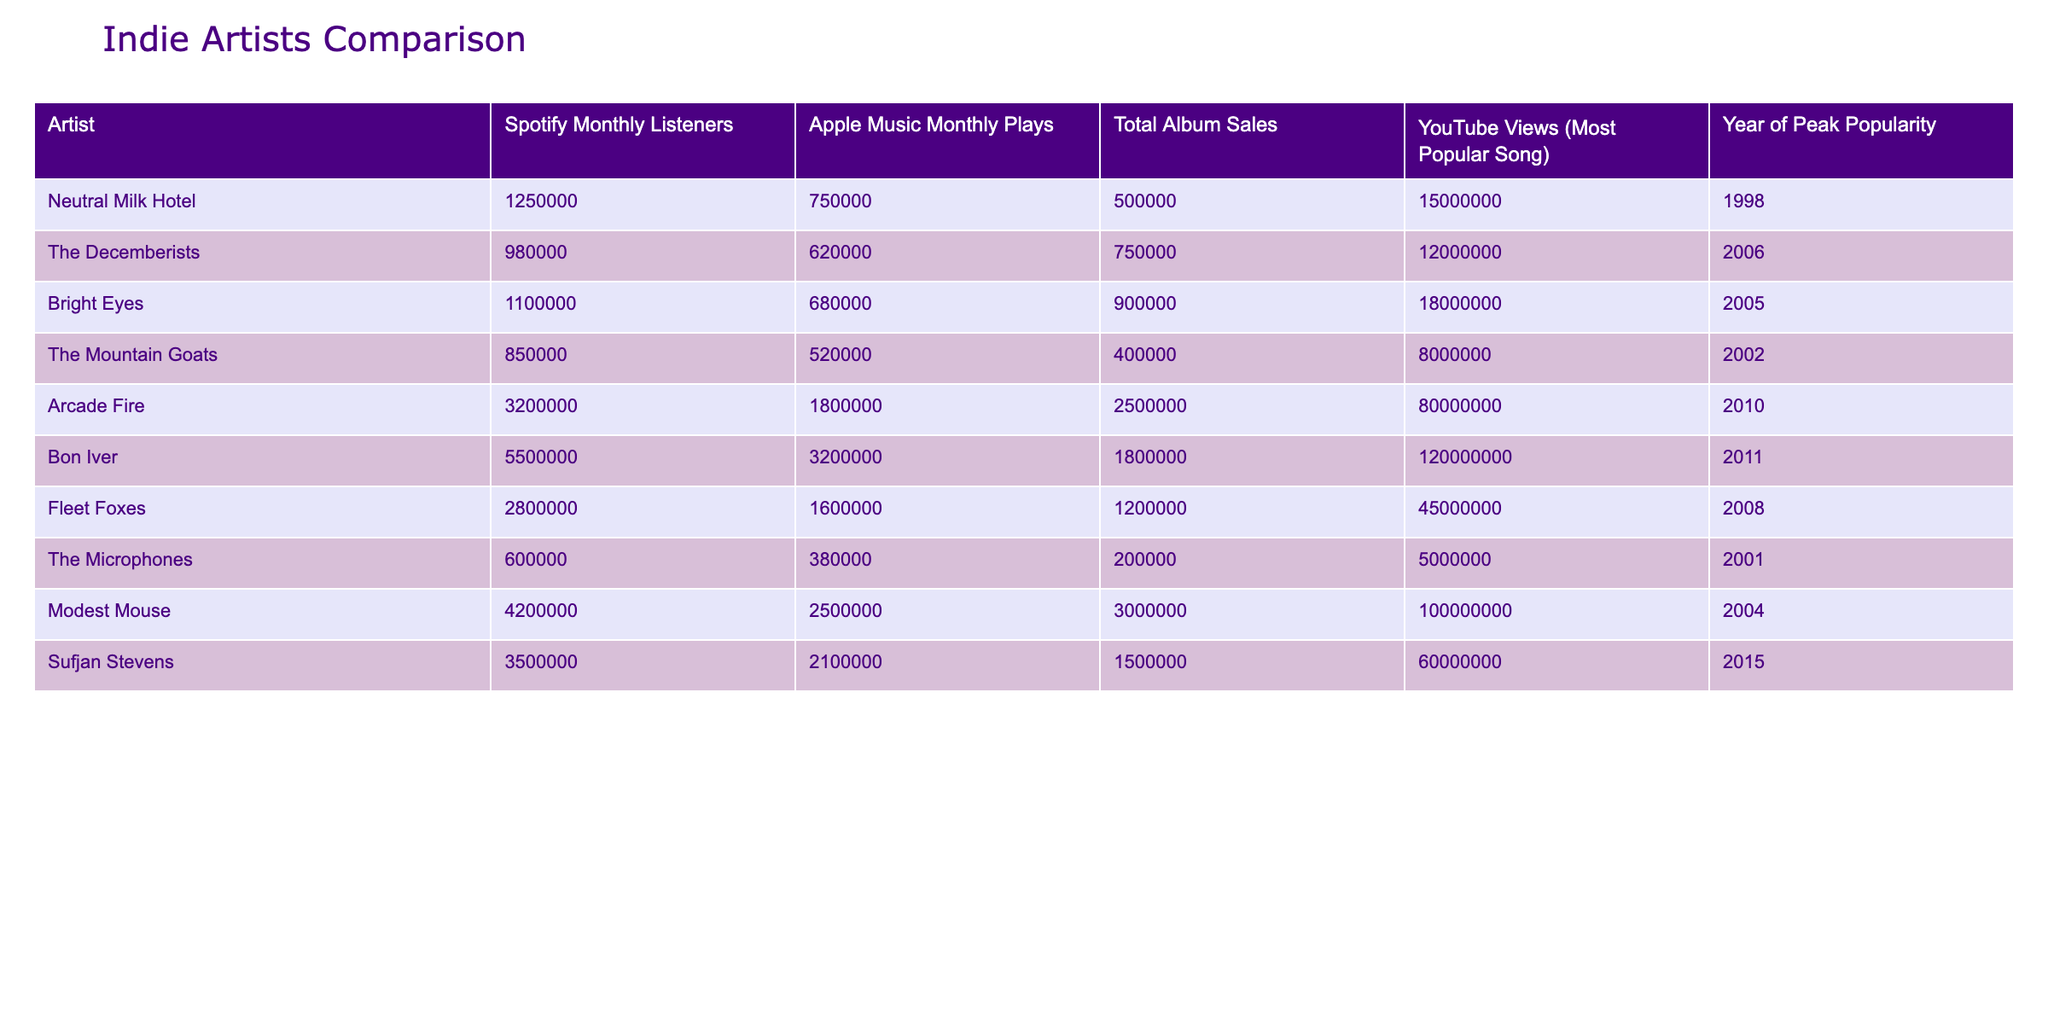What are Neutral Milk Hotel's Spotify monthly listeners? The Spotify monthly listeners for Neutral Milk Hotel is listed in the table under the corresponding column, showing 1,250,000.
Answer: 1,250,000 Which artist has the highest total album sales? By comparing the "Total Album Sales" column, Arcade Fire has the highest at 2,500,000 compared to the others listed.
Answer: Arcade Fire What is the difference in Apple Music monthly plays between Bon Iver and The Decemberists? Bon Iver has 3,200,000 Apple Music monthly plays, while The Decemberists have 620,000. The difference is 3,200,000 - 620,000 = 2,580,000.
Answer: 2,580,000 Did Fleet Foxes have their peak popularity before 2010? Fleet Foxes' year of peak popularity is 2008, which is indeed before 2010.
Answer: Yes Which artist has the most YouTube views for their most popular song? The table shows that Bon Iver has the highest YouTube views at 120,000,000, indicating they have the most compared to others listed.
Answer: Bon Iver What is the average number of Spotify monthly listeners for all artists listed? To find the average, add up all the Spotify monthly listeners (1,250,000 + 980,000 + 1,100,000 + 850,000 + 3,200,000 + 5,500,000 + 2,800,000 + 600,000 + 4,200,000 + 3,500,000) = 20,560,000. Then divide by the number of artists (10): 20,560,000 / 10 = 2,056,000.
Answer: 2,056,000 Who had a peak popularity year closest to Neutral Milk Hotel? By examining the "Year of Peak Popularity", both Bright Eyes (2005) and The Decemberists (2006) have years that are close to Neutral Milk Hotel's year (1998) but are after it. Among those, Bright Eyes is the closest.
Answer: Bright Eyes What is the total of Apple Music monthly plays for Neutral Milk Hotel, The Mountain Goats, and The Microphones? Add the Apple Music monthly plays for these three: 750,000 (Neutral Milk Hotel) + 520,000 (The Mountain Goats) + 380,000 (The Microphones) = 1,650,000.
Answer: 1,650,000 